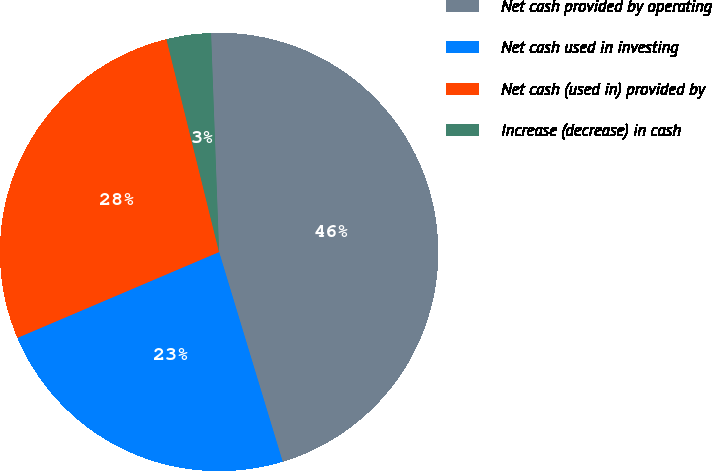Convert chart to OTSL. <chart><loc_0><loc_0><loc_500><loc_500><pie_chart><fcel>Net cash provided by operating<fcel>Net cash used in investing<fcel>Net cash (used in) provided by<fcel>Increase (decrease) in cash<nl><fcel>45.9%<fcel>23.28%<fcel>27.55%<fcel>3.27%<nl></chart> 